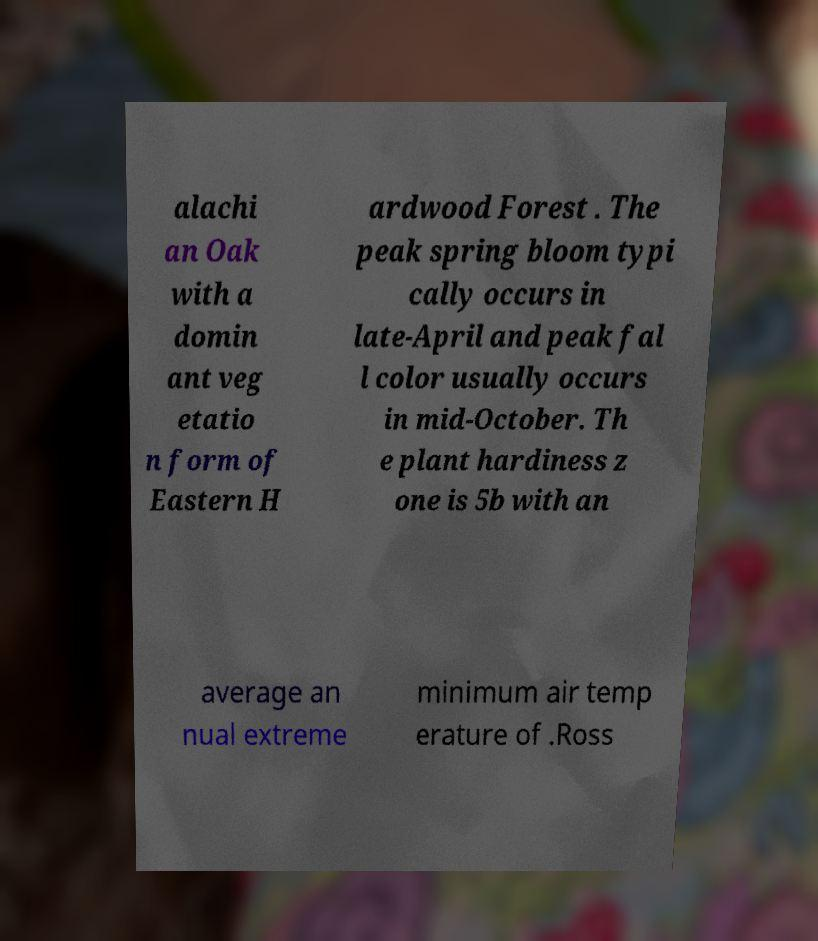Can you read and provide the text displayed in the image?This photo seems to have some interesting text. Can you extract and type it out for me? alachi an Oak with a domin ant veg etatio n form of Eastern H ardwood Forest . The peak spring bloom typi cally occurs in late-April and peak fal l color usually occurs in mid-October. Th e plant hardiness z one is 5b with an average an nual extreme minimum air temp erature of .Ross 